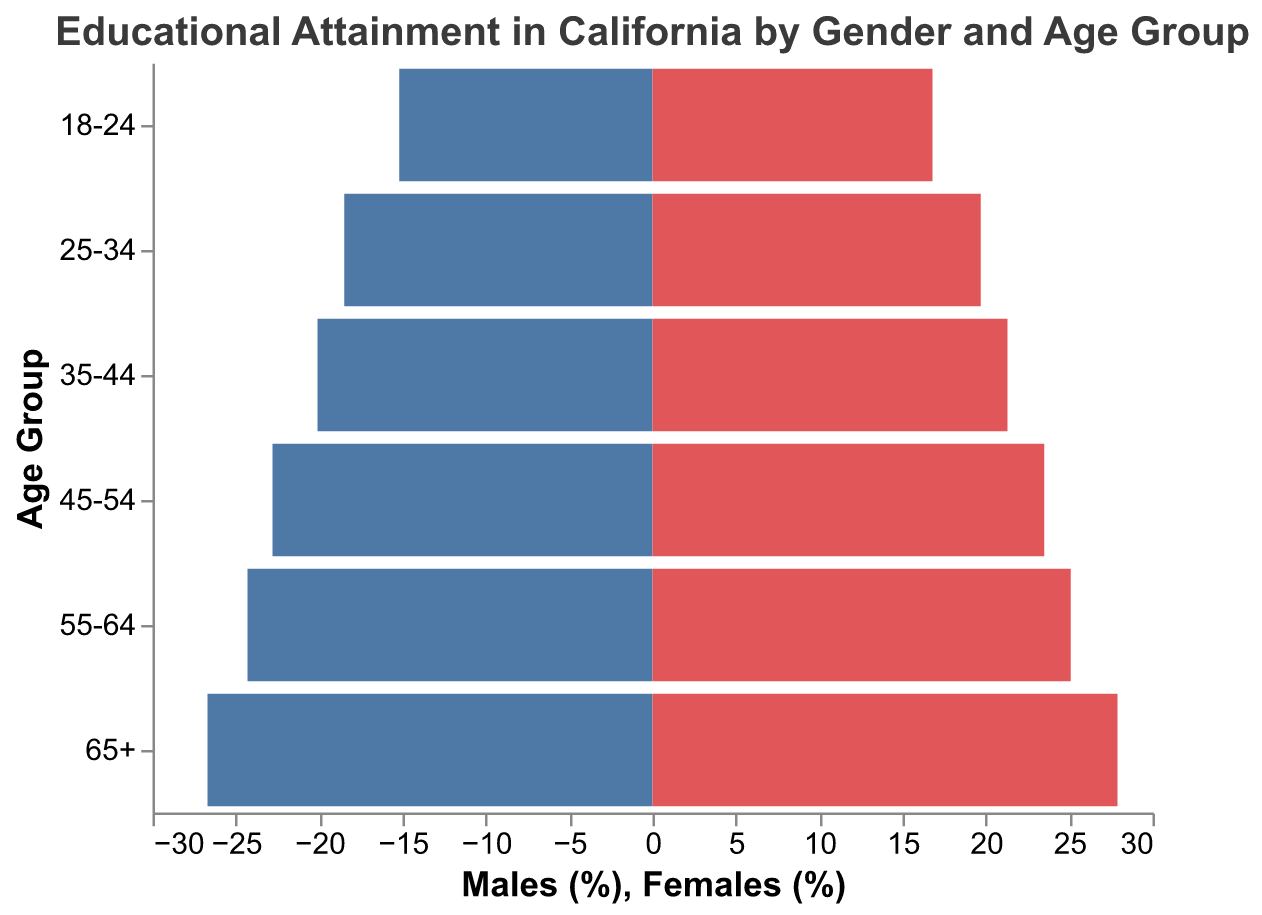What is the age group with the highest educational attainment for females? By examining the heights of the bars labeled "Females," we can see that the 65+ age group has the tallest bar, indicating the highest educational attainment rate.
Answer: 65+ In the 18-24 age group, which gender has a higher educational attainment percentage? By comparing the heights of the bars for the 18-24 age group, we see that the bar for females is taller than the bar for males, indicating higher educational attainment for females.
Answer: Females What is the difference in educational attainment between males and females in the 45-54 age group? The educational attainment for males is 22.8% and for females is 23.5%. The difference is calculated as 23.5 - 22.8 = 0.7%.
Answer: 0.7% Which age group has the smallest gender gap in educational attainment? By examining the differences between the lengths of the male and female bars, the smallest difference appears in the 25-34 age group, where the difference is 19.7 - 18.5 = 1.2%.
Answer: 25-34 How does educational attainment for males change as age increases from 18-24 to 65+? For each age group from 18-24 to 65+, the heights of the bars for males steadily increase, indicating an increase in educational attainment with age.
Answer: Increases By how much does educational attainment for females increase from the 25-34 to the 35-44 age group? Educational attainment for females in the 25-34 age group is 19.7%, and in the 35-44 age group, it is 21.3%. The difference is 21.3 - 19.7 = 1.6%.
Answer: 1.6% Which age group shows the largest gender difference in educational attainment percentages? First we calculate the differences for each age group: 18-24 is 16.8 - 15.2 = 1.6%, 25-34 is 19.7 - 18.5 = 1.2%, 35-44 is 21.3 - 20.1 = 1.2%, 45-54 is 23.5 - 22.8 = 0.7%, 55-64 is 25.1 - 24.3 = 0.8%, 65+ is 27.9 - 26.7 = 1.2%. The largest difference is found in the 18-24 age group.
Answer: 18-24 What is the trend in female educational attainment from the youngest to the oldest age group? By examining the heights of the bars for females from the 18-24 age group to the 65+ age group, it is clear that educational attainment consistently increases with age.
Answer: Increasing How do the educational attainment percentages of the 35-44 age group compare between males and females? The educational attainment for males in this age group is 20.1%, while for females it is 21.3%. Hence, females have a higher educational attainment percentage by 1.2%.
Answer: Females have a higher percentage Which gender has a greater overall educational attainment across all age groups depicted in the chart? Summing up the educational attainment percentages for each gender:
Males: 15.2 + 18.5 + 20.1 + 22.8 + 24.3 + 26.7 = 127.6%
Females: 16.8 + 19.7 + 21.3 + 23.5 + 25.1 + 27.9 = 134.3%
Females exhibit higher overall educational attainment.
Answer: Females 